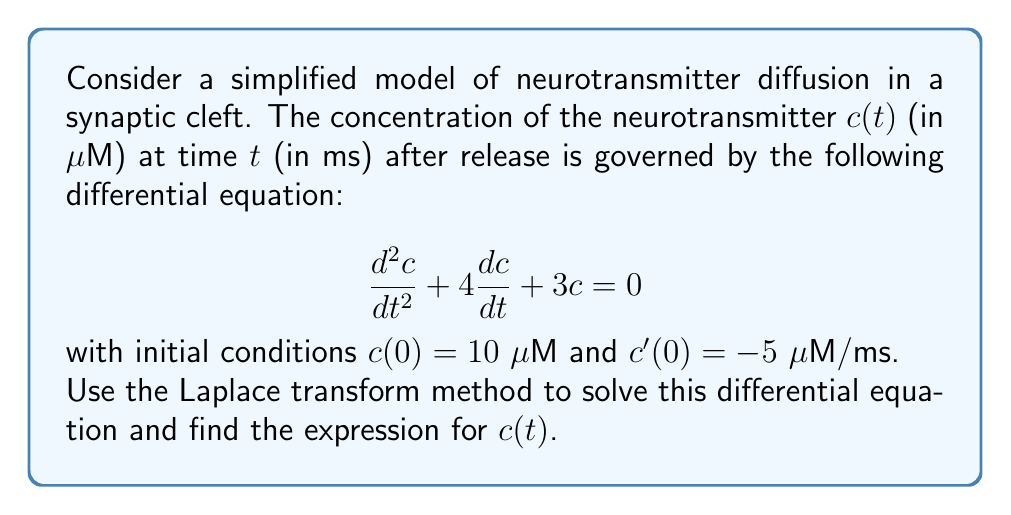Help me with this question. Let's solve this step-by-step using the Laplace transform method:

1) First, let's define $C(s) = \mathcal{L}\{c(t)\}$ as the Laplace transform of $c(t)$.

2) Take the Laplace transform of both sides of the differential equation:

   $\mathcal{L}\{\frac{d^2c}{dt^2} + 4\frac{dc}{dt} + 3c\} = \mathcal{L}\{0\}$

3) Using Laplace transform properties:

   $s^2C(s) - sc(0) - c'(0) + 4[sC(s) - c(0)] + 3C(s) = 0$

4) Substitute the initial conditions $c(0) = 10$ and $c'(0) = -5$:

   $s^2C(s) - 10s + 5 + 4sC(s) - 40 + 3C(s) = 0$

5) Collect terms with $C(s)$:

   $(s^2 + 4s + 3)C(s) = 10s + 35$

6) Solve for $C(s)$:

   $C(s) = \frac{10s + 35}{s^2 + 4s + 3}$

7) Factor the denominator:

   $C(s) = \frac{10s + 35}{(s + 1)(s + 3)}$

8) Use partial fraction decomposition:

   $C(s) = \frac{A}{s + 1} + \frac{B}{s + 3}$

   where $A$ and $B$ are constants to be determined.

9) Solve for $A$ and $B$:

   $10s + 35 = A(s + 3) + B(s + 1)$
   
   When $s = -1$: $35 = 2A$, so $A = \frac{35}{2}$
   When $s = -3$: $5 = -2B$, so $B = -\frac{5}{2}$

10) Therefore:

    $C(s) = \frac{35/2}{s + 1} - \frac{5/2}{s + 3}$

11) Take the inverse Laplace transform:

    $c(t) = \frac{35}{2}e^{-t} - \frac{5}{2}e^{-3t}$

This is the solution to the differential equation.
Answer: $c(t) = \frac{35}{2}e^{-t} - \frac{5}{2}e^{-3t}$ 